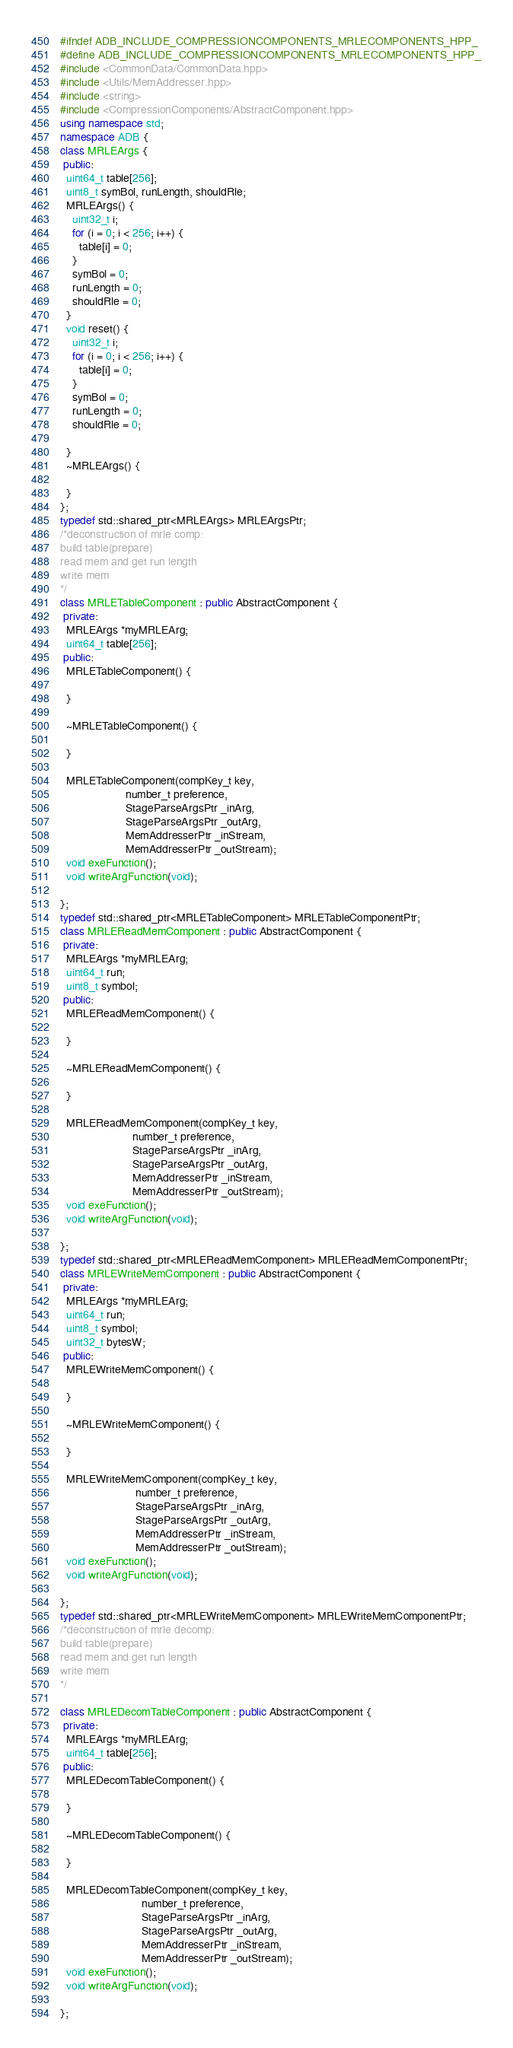<code> <loc_0><loc_0><loc_500><loc_500><_C++_>#ifndef ADB_INCLUDE_COMPRESSIONCOMPONENTS_MRLECOMPONENTS_HPP_
#define ADB_INCLUDE_COMPRESSIONCOMPONENTS_MRLECOMPONENTS_HPP_
#include <CommonData/CommonData.hpp>
#include <Utils/MemAddresser.hpp>
#include <string>
#include <CompressionComponents/AbstractComponent.hpp>
using namespace std;
namespace ADB {
class MRLEArgs {
 public:
  uint64_t table[256];
  uint8_t symBol, runLength, shouldRle;
  MRLEArgs() {
    uint32_t i;
    for (i = 0; i < 256; i++) {
      table[i] = 0;
    }
    symBol = 0;
    runLength = 0;
    shouldRle = 0;
  }
  void reset() {
    uint32_t i;
    for (i = 0; i < 256; i++) {
      table[i] = 0;
    }
    symBol = 0;
    runLength = 0;
    shouldRle = 0;

  }
  ~MRLEArgs() {

  }
};
typedef std::shared_ptr<MRLEArgs> MRLEArgsPtr;
/*deconstruction of mrle comp:
build table(prepare)
read mem and get run length
write mem
*/
class MRLETableComponent : public AbstractComponent {
 private:
  MRLEArgs *myMRLEArg;
  uint64_t table[256];
 public:
  MRLETableComponent() {

  }

  ~MRLETableComponent() {

  }

  MRLETableComponent(compKey_t key,
                     number_t preference,
                     StageParseArgsPtr _inArg,
                     StageParseArgsPtr _outArg,
                     MemAddresserPtr _inStream,
                     MemAddresserPtr _outStream);
  void exeFunction();
  void writeArgFunction(void);

};
typedef std::shared_ptr<MRLETableComponent> MRLETableComponentPtr;
class MRLEReadMemComponent : public AbstractComponent {
 private:
  MRLEArgs *myMRLEArg;
  uint64_t run;
  uint8_t symbol;
 public:
  MRLEReadMemComponent() {

  }

  ~MRLEReadMemComponent() {

  }

  MRLEReadMemComponent(compKey_t key,
                       number_t preference,
                       StageParseArgsPtr _inArg,
                       StageParseArgsPtr _outArg,
                       MemAddresserPtr _inStream,
                       MemAddresserPtr _outStream);
  void exeFunction();
  void writeArgFunction(void);

};
typedef std::shared_ptr<MRLEReadMemComponent> MRLEReadMemComponentPtr;
class MRLEWriteMemComponent : public AbstractComponent {
 private:
  MRLEArgs *myMRLEArg;
  uint64_t run;
  uint8_t symbol;
  uint32_t bytesW;
 public:
  MRLEWriteMemComponent() {

  }

  ~MRLEWriteMemComponent() {

  }

  MRLEWriteMemComponent(compKey_t key,
                        number_t preference,
                        StageParseArgsPtr _inArg,
                        StageParseArgsPtr _outArg,
                        MemAddresserPtr _inStream,
                        MemAddresserPtr _outStream);
  void exeFunction();
  void writeArgFunction(void);

};
typedef std::shared_ptr<MRLEWriteMemComponent> MRLEWriteMemComponentPtr;
/*deconstruction of mrle decomp:
build table(prepare)
read mem and get run length
write mem
*/

class MRLEDecomTableComponent : public AbstractComponent {
 private:
  MRLEArgs *myMRLEArg;
  uint64_t table[256];
 public:
  MRLEDecomTableComponent() {

  }

  ~MRLEDecomTableComponent() {

  }

  MRLEDecomTableComponent(compKey_t key,
                          number_t preference,
                          StageParseArgsPtr _inArg,
                          StageParseArgsPtr _outArg,
                          MemAddresserPtr _inStream,
                          MemAddresserPtr _outStream);
  void exeFunction();
  void writeArgFunction(void);

};</code> 